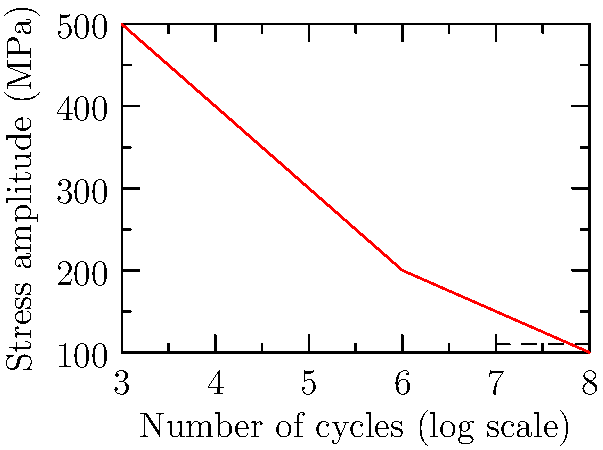Given the S-N curve for a welded joint in a bicycle frame, determine the safety factor against fatigue failure if the joint experiences a cyclic stress amplitude of 100 MPa for $10^6$ cycles. Assume the endurance limit is 110 MPa. To determine the safety factor against fatigue failure, we need to follow these steps:

1. Identify the stress amplitude and number of cycles:
   - Stress amplitude (S) = 100 MPa
   - Number of cycles (N) = $10^6$

2. Locate the endurance limit on the S-N curve:
   - Endurance limit = 110 MPa

3. Determine the allowable stress at $10^6$ cycles:
   - From the S-N curve, we can see that at $10^6$ cycles, the allowable stress is approximately 200 MPa

4. Calculate the safety factor:
   Safety Factor (SF) = $\frac{\text{Allowable Stress}}{\text{Applied Stress}}$
   
   SF = $\frac{200 \text{ MPa}}{100 \text{ MPa}} = 2$

5. Verify against the endurance limit:
   Since the applied stress (100 MPa) is below the endurance limit (110 MPa), the joint should theoretically have infinite life. However, we'll use the calculated safety factor as it's more conservative.

Therefore, the safety factor against fatigue failure for this welded joint is 2.
Answer: 2 